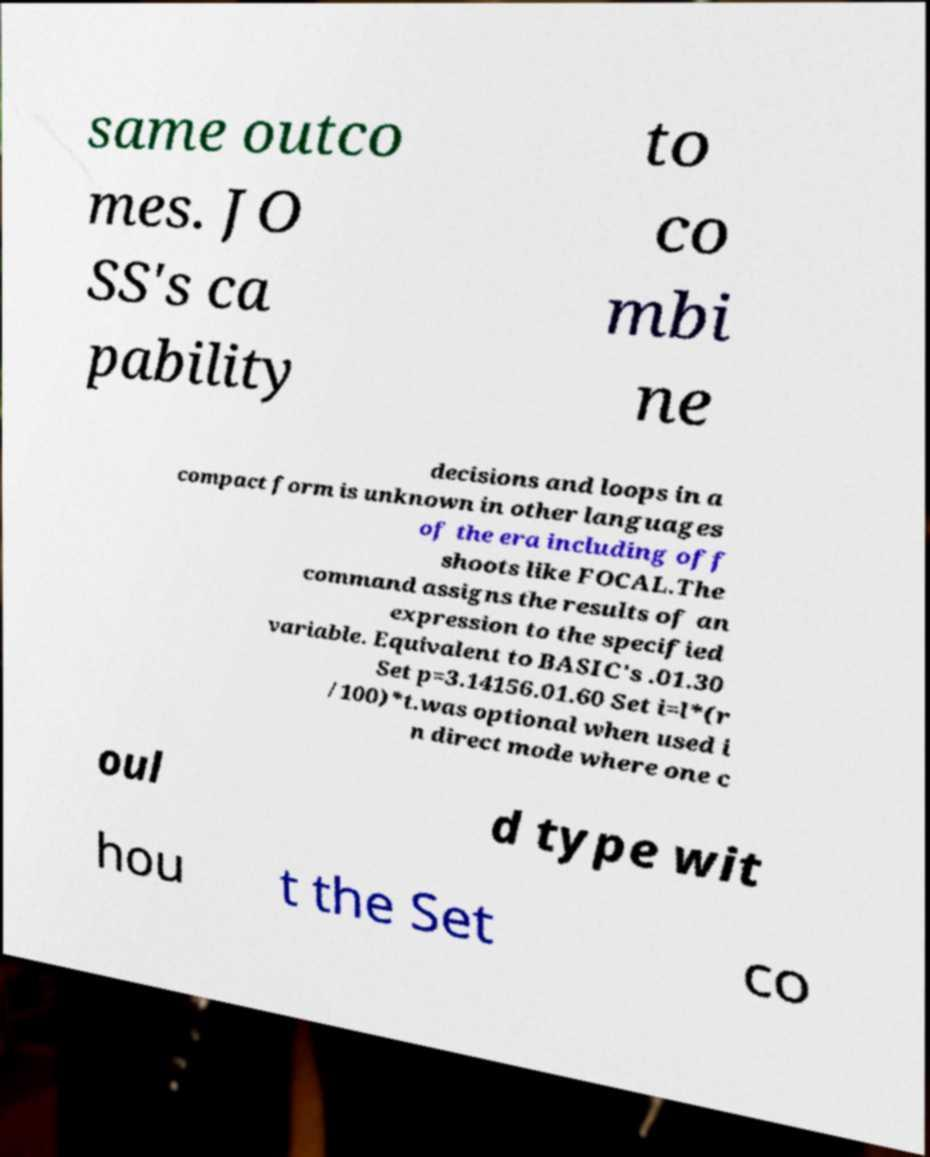What messages or text are displayed in this image? I need them in a readable, typed format. same outco mes. JO SS's ca pability to co mbi ne decisions and loops in a compact form is unknown in other languages of the era including off shoots like FOCAL.The command assigns the results of an expression to the specified variable. Equivalent to BASIC's .01.30 Set p=3.14156.01.60 Set i=l*(r /100)*t.was optional when used i n direct mode where one c oul d type wit hou t the Set co 